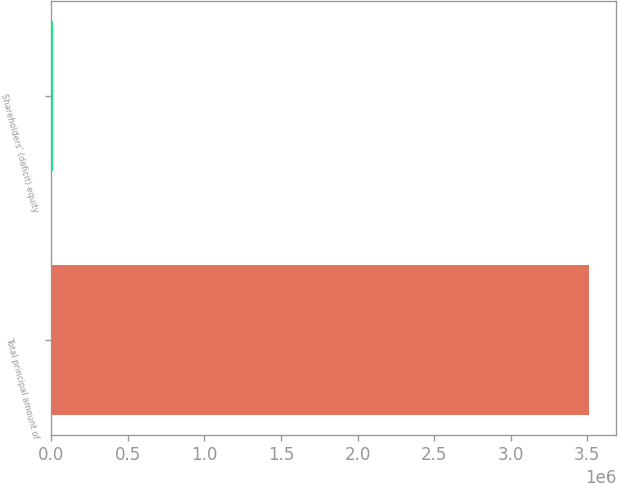Convert chart. <chart><loc_0><loc_0><loc_500><loc_500><bar_chart><fcel>Total principal amount of<fcel>Shareholders' (deficit) equity<nl><fcel>3.5125e+06<fcel>11313<nl></chart> 